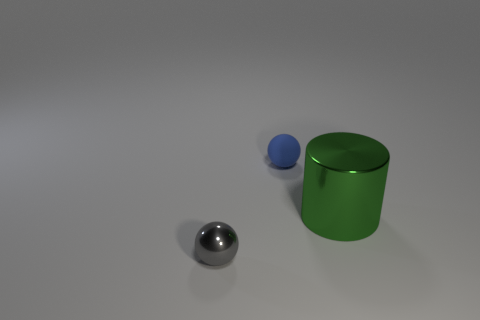What materials are the objects in the image made of? The objects in the image appear to be made of different materials. The sphere on the left looks to be made of metal, while the cylinder is likely made of a painted, matte surface, which could hint at metal or plastic, but the bright green color suggests a painted surface. The small sphere on the right has a color and sheen that suggest it's made of rubber.  Can you guess the approximate size of these objects? Judging by the image without a clear reference for scale, it's challenging to determine the exact sizes. However, if we assume the large cylinder is about the height of a standard coffee mug, we could estimate the metal sphere to be roughly the size of a marble, and the tiny blue sphere could be compared to a small bouncy ball. 